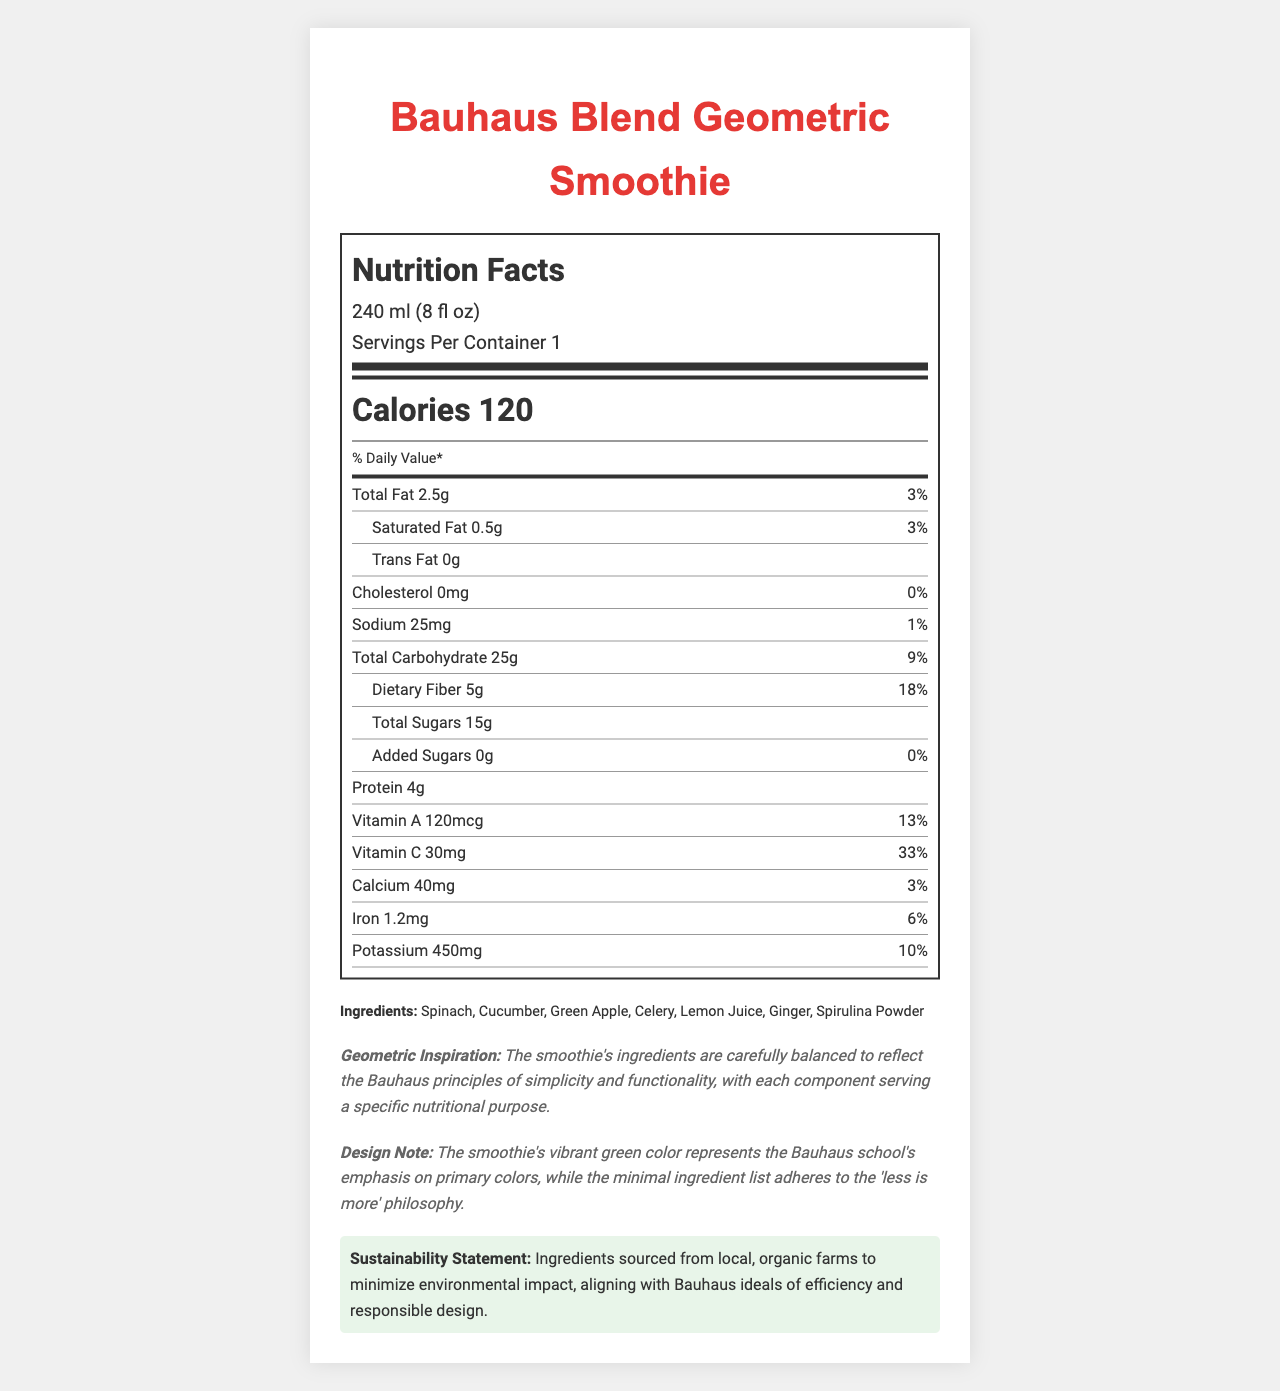what is the serving size? The serving size is listed at the top of the Nutrition Facts under the "Nutrition Facts" header.
Answer: 240 ml (8 fl oz) how many grams of protein are in one serving? The protein content is listed as 4 grams under the nutrient section of the Nutrition Facts label.
Answer: 4g how much Vitamin C does the smoothie contain per serving? Vitamin C is listed in the nutrient section, showing 30mg per serving.
Answer: 30mg Does the smoothie contain any added sugars? According to the label, the amount of added sugars is 0 grams, which is 0% of the daily value.
Answer: No what ingredients are in the smoothie? The ingredients are listed at the bottom of the label under the "Ingredients" section.
Answer: Spinach, Cucumber, Green Apple, Celery, Lemon Juice, Ginger, Spirulina Powder What is the daily value percentage of dietary fiber per serving? The daily value percentage of dietary fiber is given as 18% in the nutrient section.
Answer: 18% how many calories are in one serving of the smoothie? The number of calories per serving is displayed prominently in the "Calories" section.
Answer: 120 Does the smoothie contain cholesterol? The cholesterol section indicates that there is 0mg of cholesterol, which is 0% of the daily value.
Answer: No What is the main idea of this document? The document includes nutritional information per serving, a list of ingredients, and notes on geometric inspiration, design, and sustainability consistent with the Bauhaus philosophy of simplicity and functionality.
Answer: The document is a nutrition facts label for the "Bauhaus Blend Geometric Smoothie", detailing its nutritional content, ingredients, and design inspiration aligned with Bauhaus principles. What is the daily value percentage of potassium per serving? A. 5% B. 10% C. 20% D. 30% The daily value percentage of potassium is listed as 10% in the nutrient section.
Answer: B Is there any information about the manufacturing process? The allergen information specifies that the product is processed in a facility that also processes tree nuts and soy.
Answer: Yes What percentage of the daily value is the sodium content? The sodium content per serving has a daily value of 1%, as indicated in the nutrient section.
Answer: 1% What is the vibrant green color of the smoothie meant to represent? The design note mentions that the vibrant green color represents the Bauhaus school's emphasis on primary colors.
Answer: The Bauhaus school's emphasis on primary colors How are the ingredients sourced according to the sustainability statement? The sustainability statement at the bottom of the label mentions that ingredients are sourced from local, organic farms to minimize environmental impact.
Answer: From local, organic farms How much total carbohydrates does one serving of the smoothie contain? The nutrient section lists total carbohydrates at 25 grams per serving.
Answer: 25g What specific nutritional purpose does each ingredient serve? The document does not provide detailed information on the specific nutritional purpose of each individual ingredient; it only states that each component serves a specific nutritional purpose.
Answer: Not enough information 